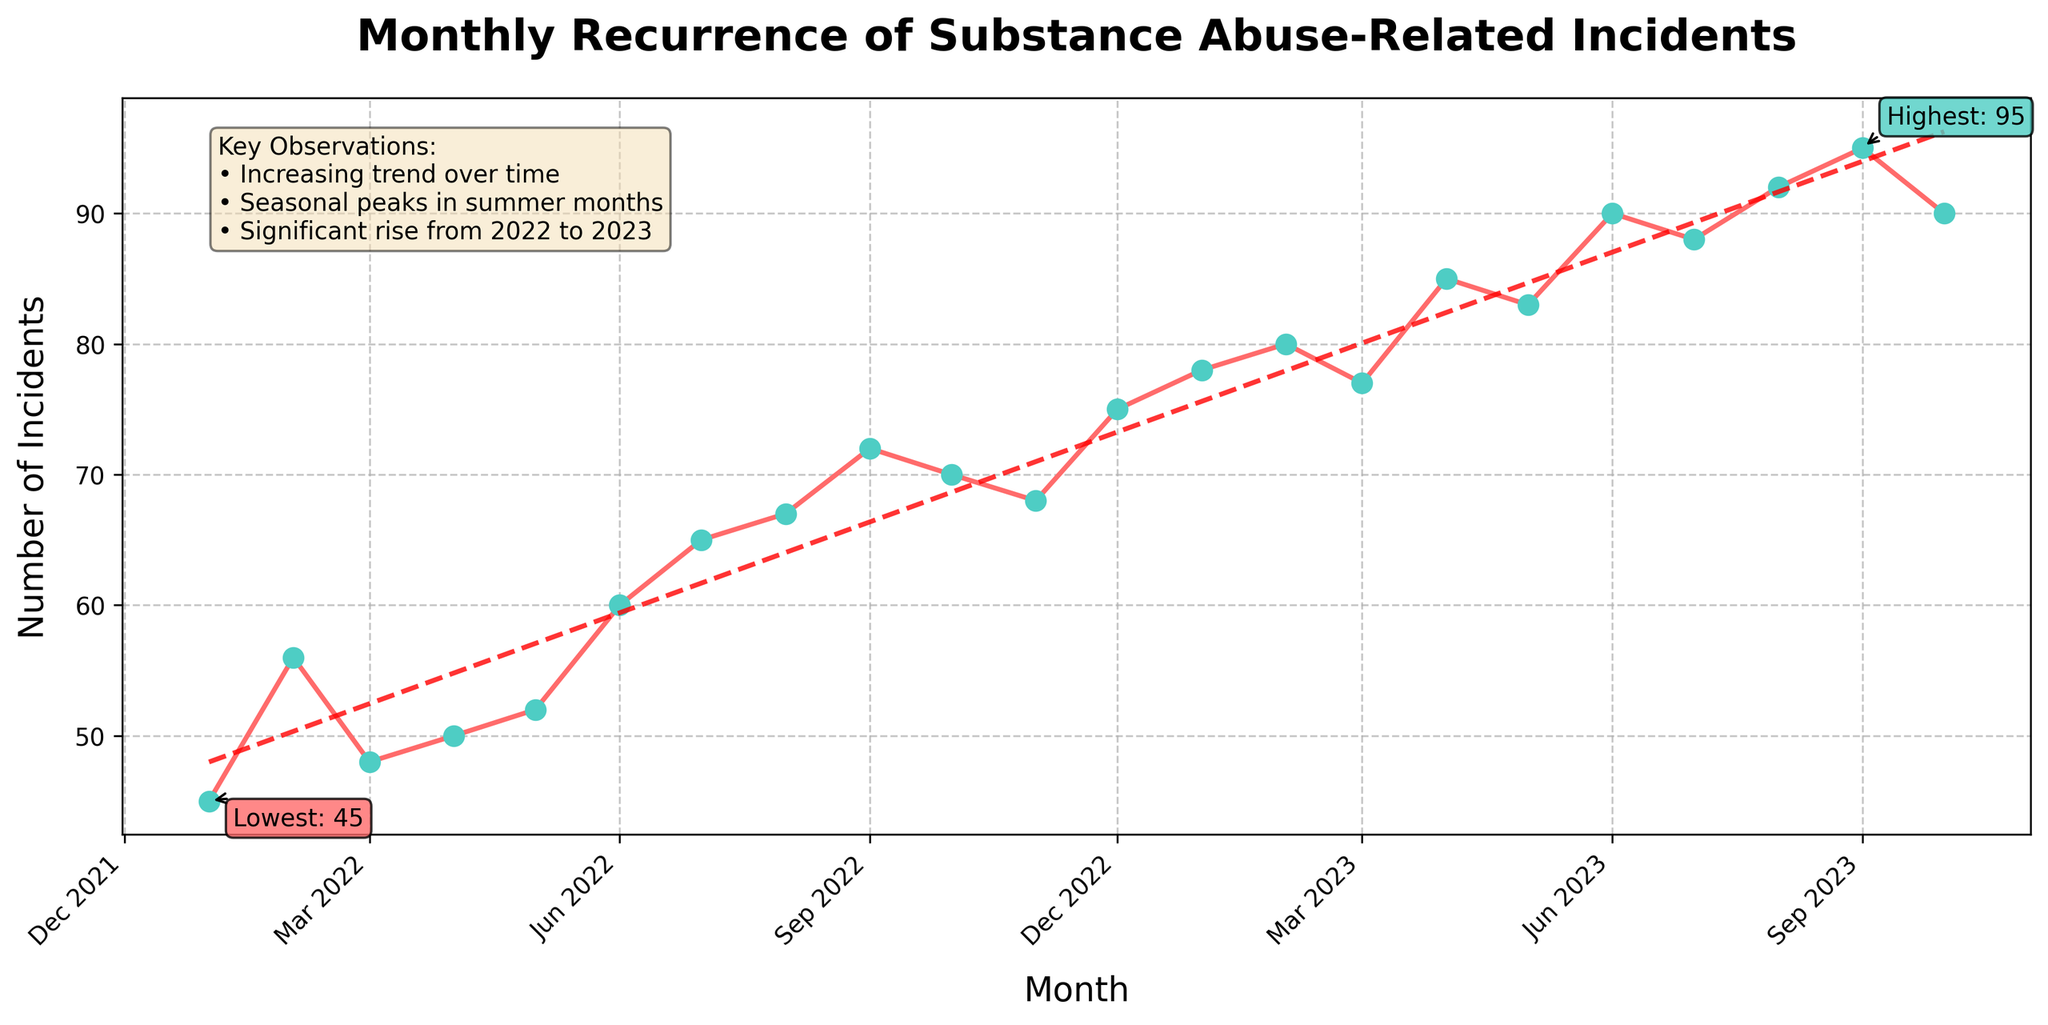What is the title of the plot? The title of the plot is displayed at the very top of the figure, usually in a larger and bold font for visibility. It provides a quick understanding of what the plot represents.
Answer: Monthly Recurrence of Substance Abuse-Related Incidents What are the basic units on the x-axis? The x-axis is labeled to indicate the time frame of the data, which helps in understanding the timeline and period of events being analyzed. By rotating the labels 45 degrees, the months and years are made more readable.
Answer: Month How many incidents were recorded in December 2022? The data point corresponding to December 2022 can be identified on the x-axis, and the value on the y-axis directly above this point indicates the number of incidents.
Answer: 75 What is the general trend of substance abuse incidents over the displayed period? By looking at the overall direction of the line graph from the start to the end, one can determine whether the number of incidents is increasing, decreasing, or staying constant over time.
Answer: Increasing trend Which month had the highest number of substance abuse incidents, and what is that value? The annotation markers highlight the highest incidents point in the plot, and it is noted directly with a text box alongside the point.
Answer: September 2023, 95 Which month had the lowest number of substance abuse incidents, and what is that value? The annotation markers highlight the lowest incidents point in the plot, and it is noted directly with a text box alongside the point.
Answer: January 2022, 45 What observations can be made about seasonal variations in substance abuse incidents? Key observations, usually summarized in a text box on the plot, note any visible patterns such as higher incidents in certain seasons or months.
Answer: Peaks in summer months What is the difference in incidents between January 2022 and January 2023? By identifying the data points for January 2022 and January 2023 on the plot, we can subtract the number of incidents of the former from the latter to understand the difference in incidents over a year.
Answer: 33 During which period did substance abuse incidents see a significant rise? Observing the overall trend line, particularly the sections where the line shows a steep upward slope, helps identify when the most significant increases occurred in the data.
Answer: From 2022 to 2023 